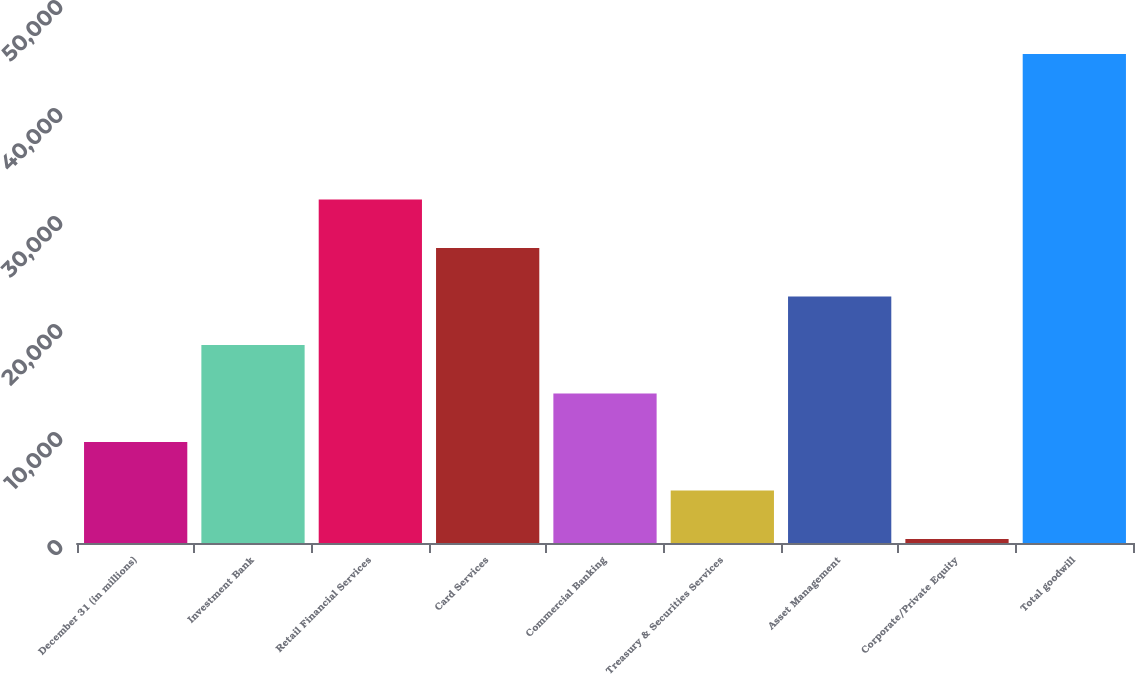Convert chart to OTSL. <chart><loc_0><loc_0><loc_500><loc_500><bar_chart><fcel>December 31 (in millions)<fcel>Investment Bank<fcel>Retail Financial Services<fcel>Card Services<fcel>Commercial Banking<fcel>Treasury & Securities Services<fcel>Asset Management<fcel>Corporate/Private Equity<fcel>Total goodwill<nl><fcel>9355.6<fcel>18334.2<fcel>31802.1<fcel>27312.8<fcel>13844.9<fcel>4866.3<fcel>22823.5<fcel>377<fcel>45270<nl></chart> 